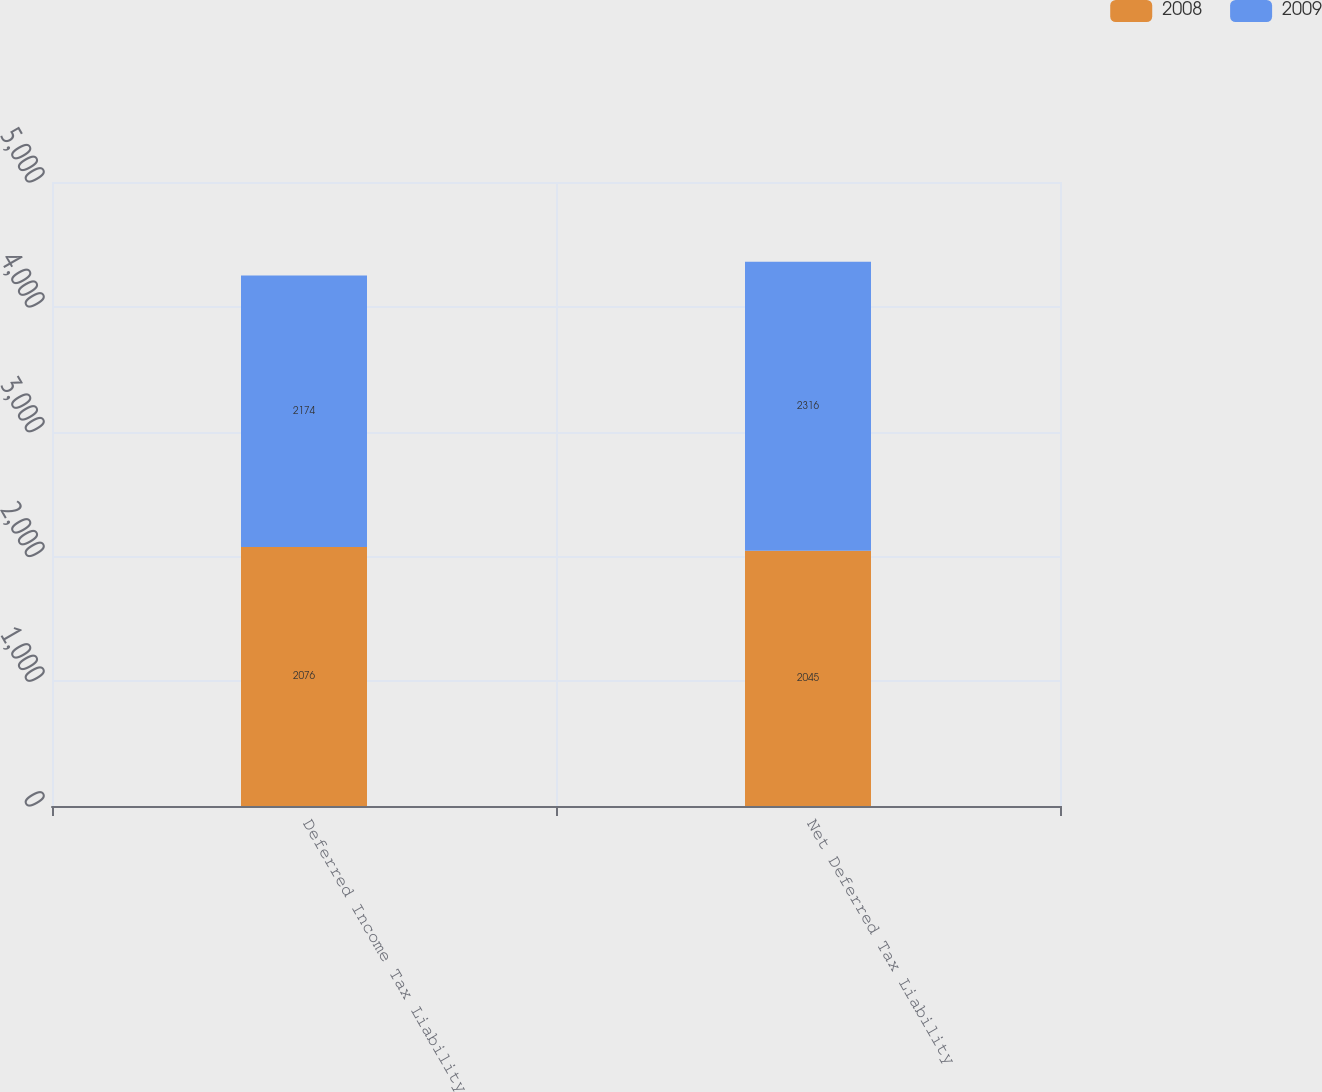<chart> <loc_0><loc_0><loc_500><loc_500><stacked_bar_chart><ecel><fcel>Deferred Income Tax Liability<fcel>Net Deferred Tax Liability<nl><fcel>2008<fcel>2076<fcel>2045<nl><fcel>2009<fcel>2174<fcel>2316<nl></chart> 